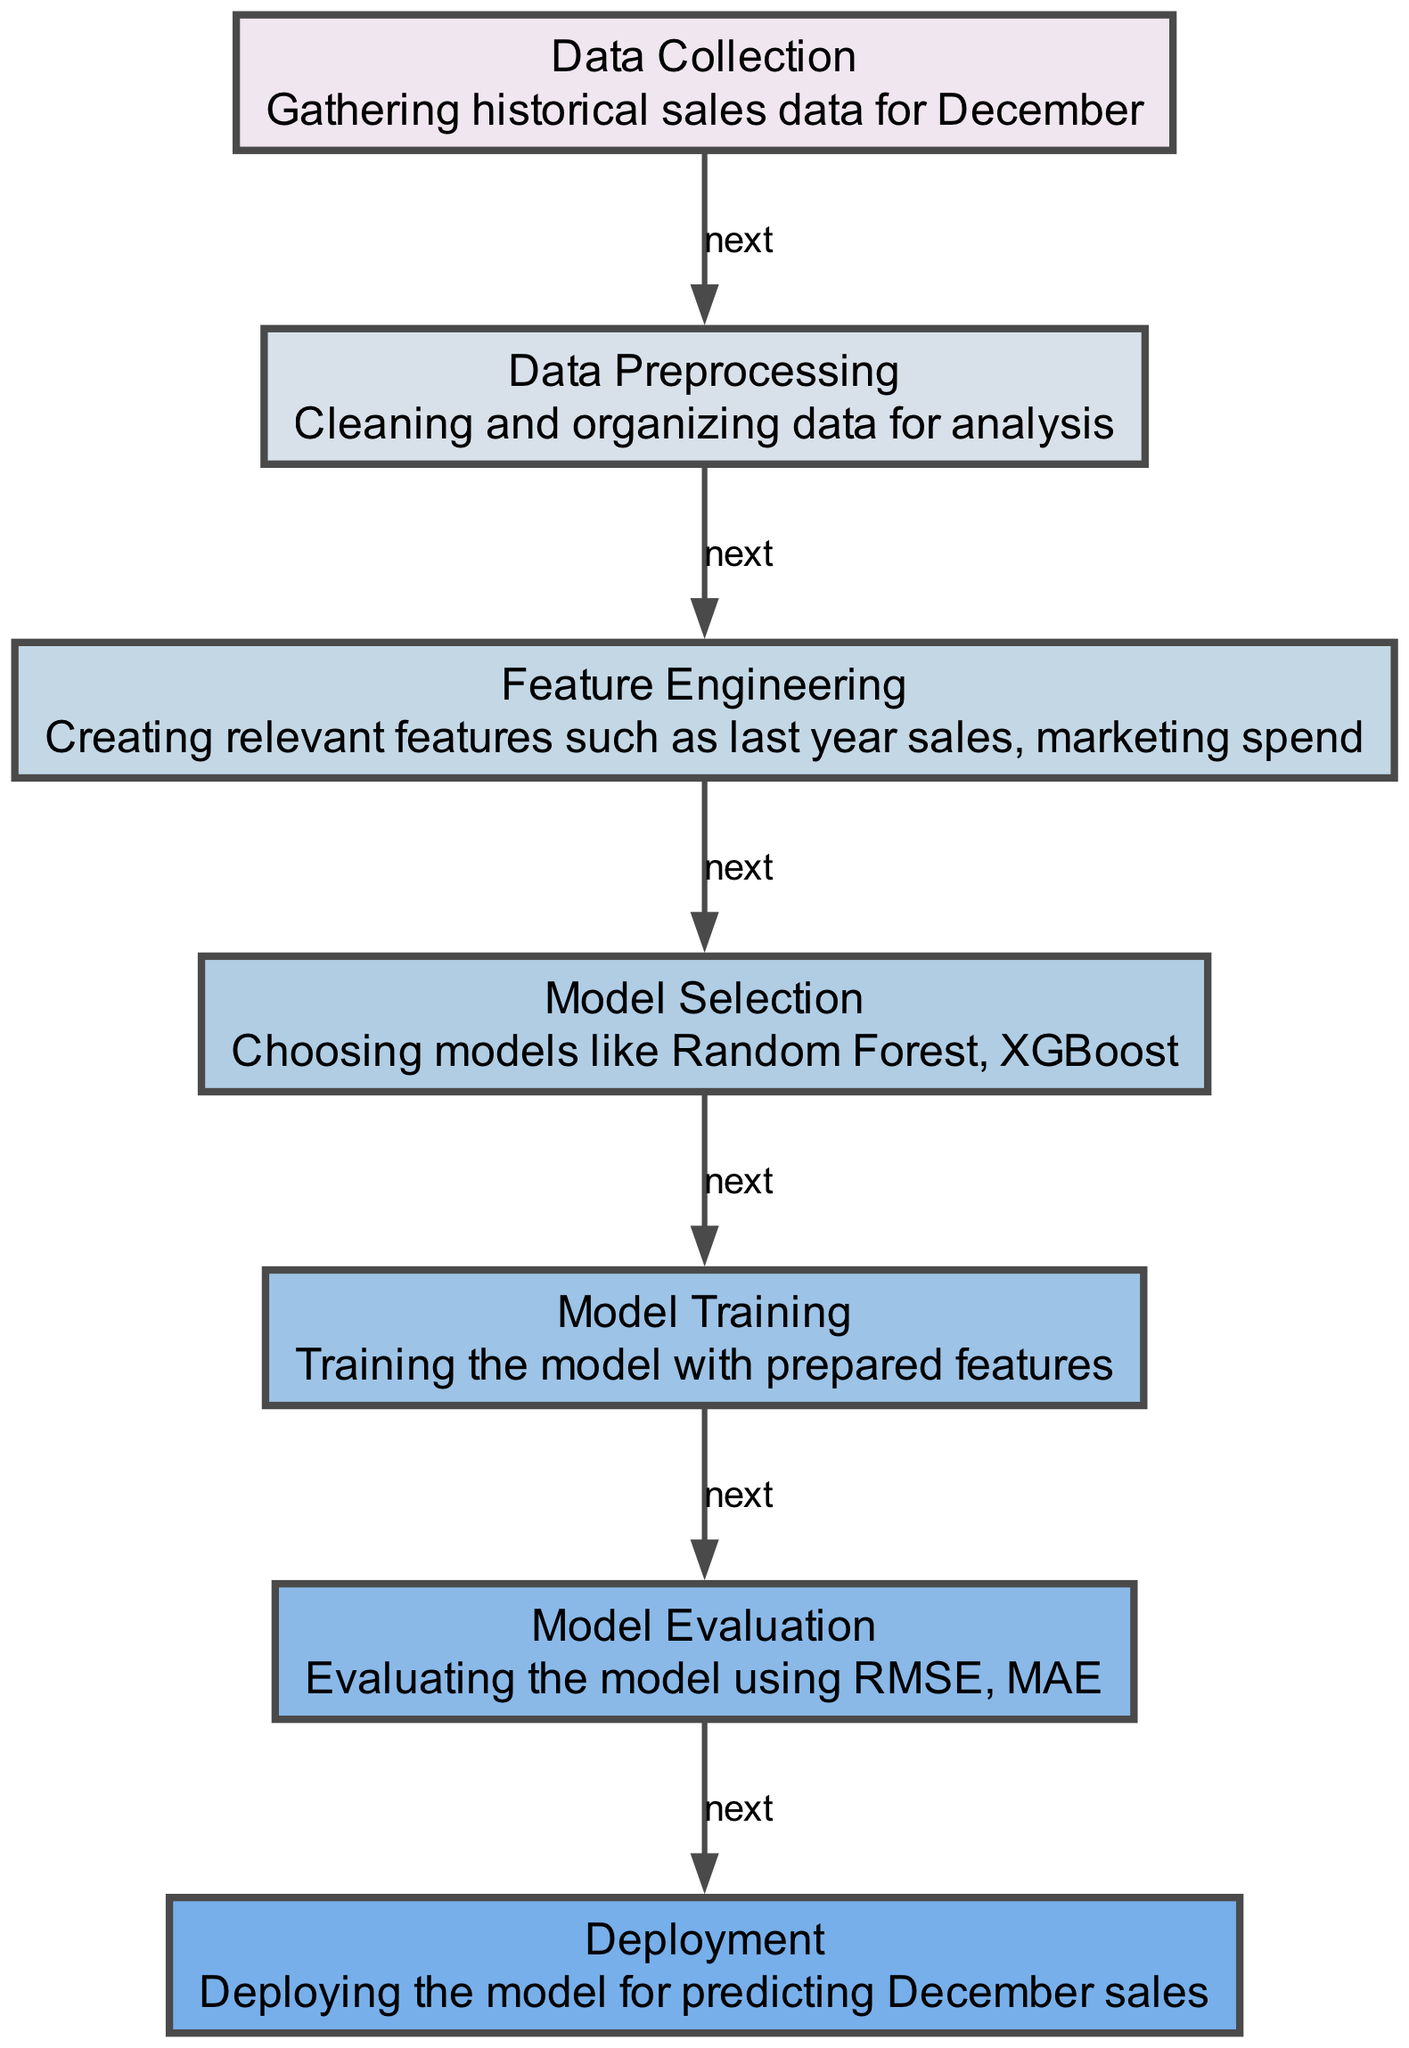What is the first step in the diagram? The diagram starts with the "Data Collection" node, which indicates that the first step is gathering historical sales data for December.
Answer: Data Collection How many nodes are there in the diagram? By counting the number of unique nodes in the diagram, we find there are seven nodes that represent different steps in the predictive analytics process.
Answer: Seven What are the last two steps in the process? The diagram shows that the last two steps are "Model Evaluation," which is followed by "Deployment," indicating the final stages of the process.
Answer: Model Evaluation, Deployment Which node describes cleaning and organizing data? The node labeled "Data Preprocessing" specifically describes the process of cleaning and organizing data for analysis.
Answer: Data Preprocessing What is evaluated using RMSE and MAE? The node "Model Evaluation" mentions that the performance of the model is evaluated using RMSE (Root Mean Square Error) and MAE (Mean Absolute Error).
Answer: Model Evaluation Which step follows Feature Engineering? According to the directed flow in the diagram, "Model Selection" is the step that follows "Feature Engineering," where models are chosen for training.
Answer: Model Selection What is the purpose of the "Deployment" node? The "Deployment" node indicates that its purpose is to deploy the model that has been trained and evaluated, for predicting future December sales.
Answer: Deploying the model for predicting December sales What type of models are mentioned in the "Model Selection" step? The "Model Selection" node specifies that models like Random Forest and XGBoost are chosen during this step of the process.
Answer: Random Forest, XGBoost How does the model progress from training to evaluation? The diagram shows an edge from "Model Training" to "Model Evaluation," indicating that after training the model, it proceeds to evaluation to test its performance.
Answer: Model Evaluation 